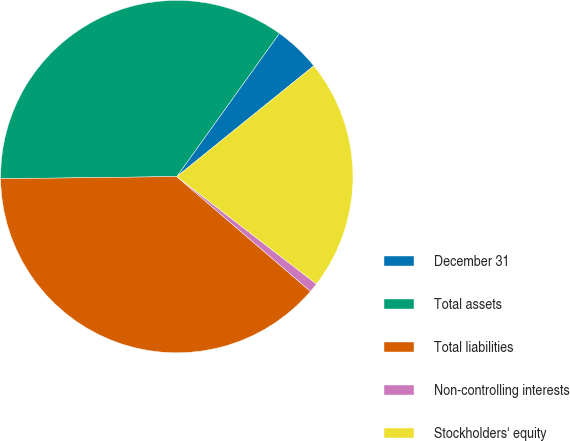Convert chart. <chart><loc_0><loc_0><loc_500><loc_500><pie_chart><fcel>December 31<fcel>Total assets<fcel>Total liabilities<fcel>Non-controlling interests<fcel>Stockholders' equity<nl><fcel>4.29%<fcel>35.09%<fcel>38.51%<fcel>0.86%<fcel>21.25%<nl></chart> 